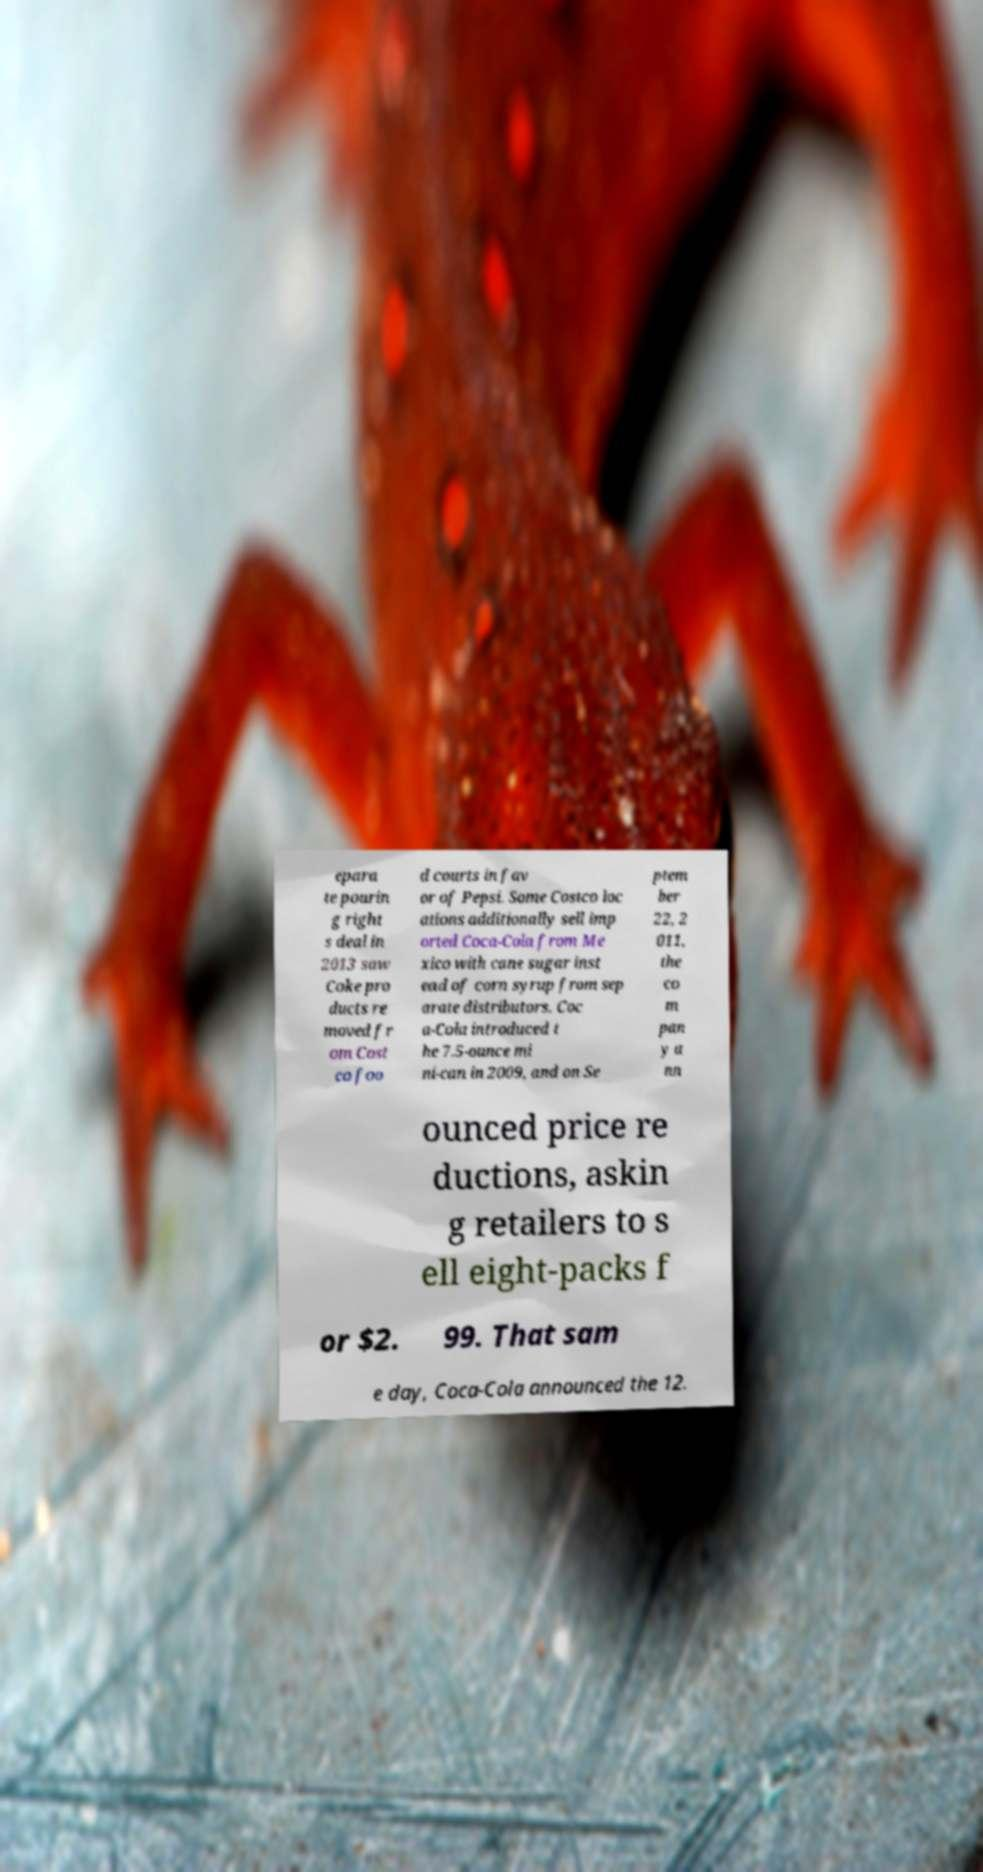Can you accurately transcribe the text from the provided image for me? epara te pourin g right s deal in 2013 saw Coke pro ducts re moved fr om Cost co foo d courts in fav or of Pepsi. Some Costco loc ations additionally sell imp orted Coca-Cola from Me xico with cane sugar inst ead of corn syrup from sep arate distributors. Coc a-Cola introduced t he 7.5-ounce mi ni-can in 2009, and on Se ptem ber 22, 2 011, the co m pan y a nn ounced price re ductions, askin g retailers to s ell eight-packs f or $2. 99. That sam e day, Coca-Cola announced the 12. 